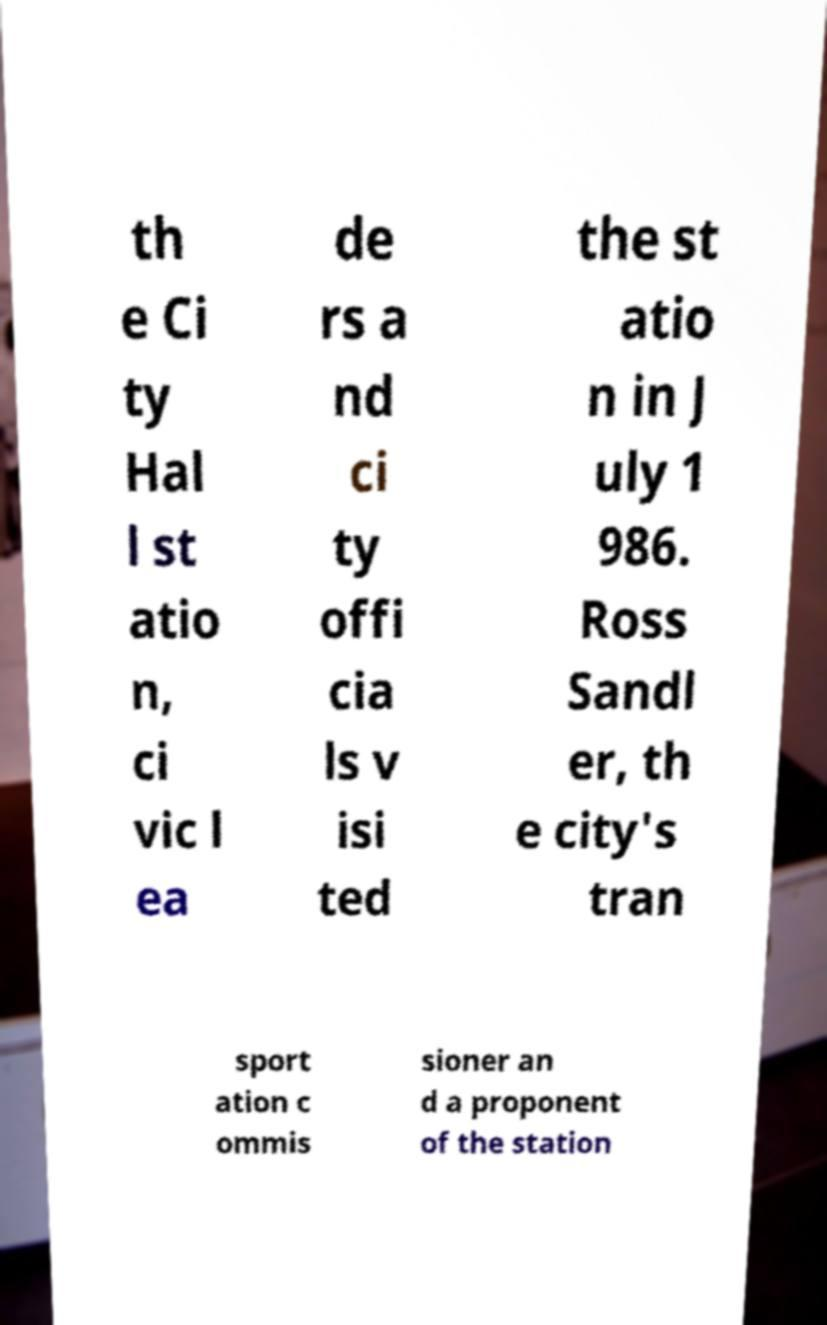For documentation purposes, I need the text within this image transcribed. Could you provide that? th e Ci ty Hal l st atio n, ci vic l ea de rs a nd ci ty offi cia ls v isi ted the st atio n in J uly 1 986. Ross Sandl er, th e city's tran sport ation c ommis sioner an d a proponent of the station 